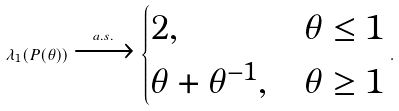<formula> <loc_0><loc_0><loc_500><loc_500>\lambda _ { 1 } ( P ( \theta ) ) \xrightarrow [ ] { a . s . } \begin{cases} 2 , & \theta \leq 1 \\ \theta + \theta ^ { - 1 } , & \theta \geq 1 \end{cases} .</formula> 